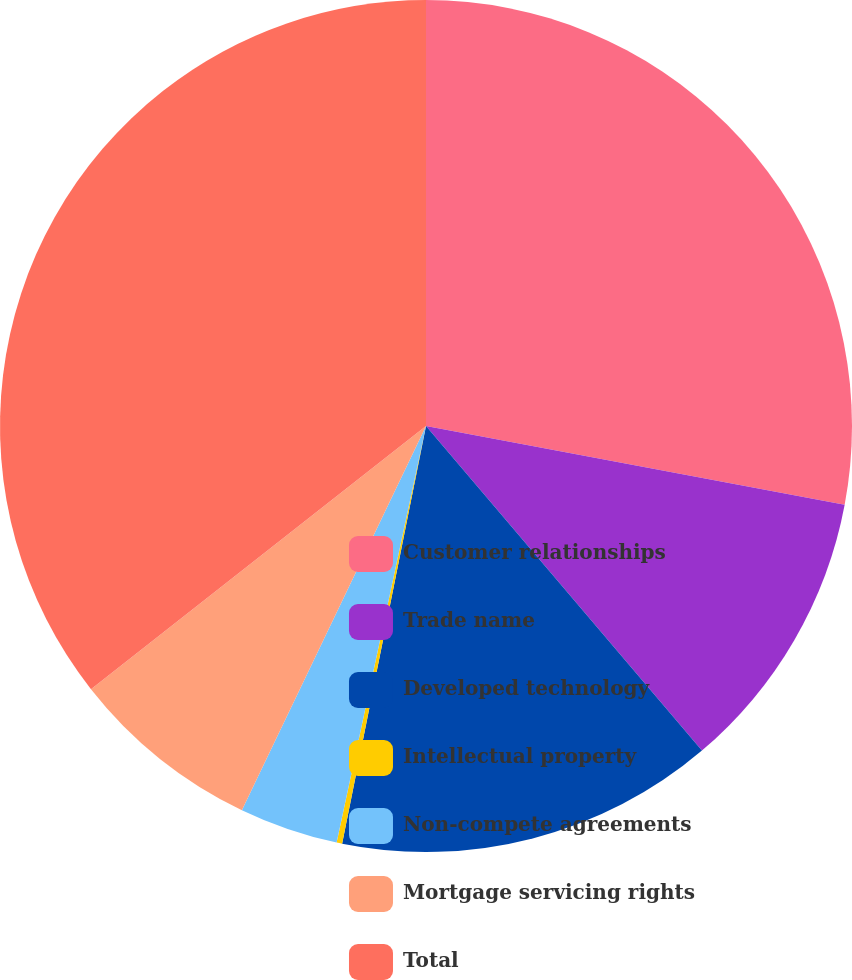<chart> <loc_0><loc_0><loc_500><loc_500><pie_chart><fcel>Customer relationships<fcel>Trade name<fcel>Developed technology<fcel>Intellectual property<fcel>Non-compete agreements<fcel>Mortgage servicing rights<fcel>Total<nl><fcel>27.96%<fcel>10.83%<fcel>14.37%<fcel>0.21%<fcel>3.75%<fcel>7.29%<fcel>35.6%<nl></chart> 